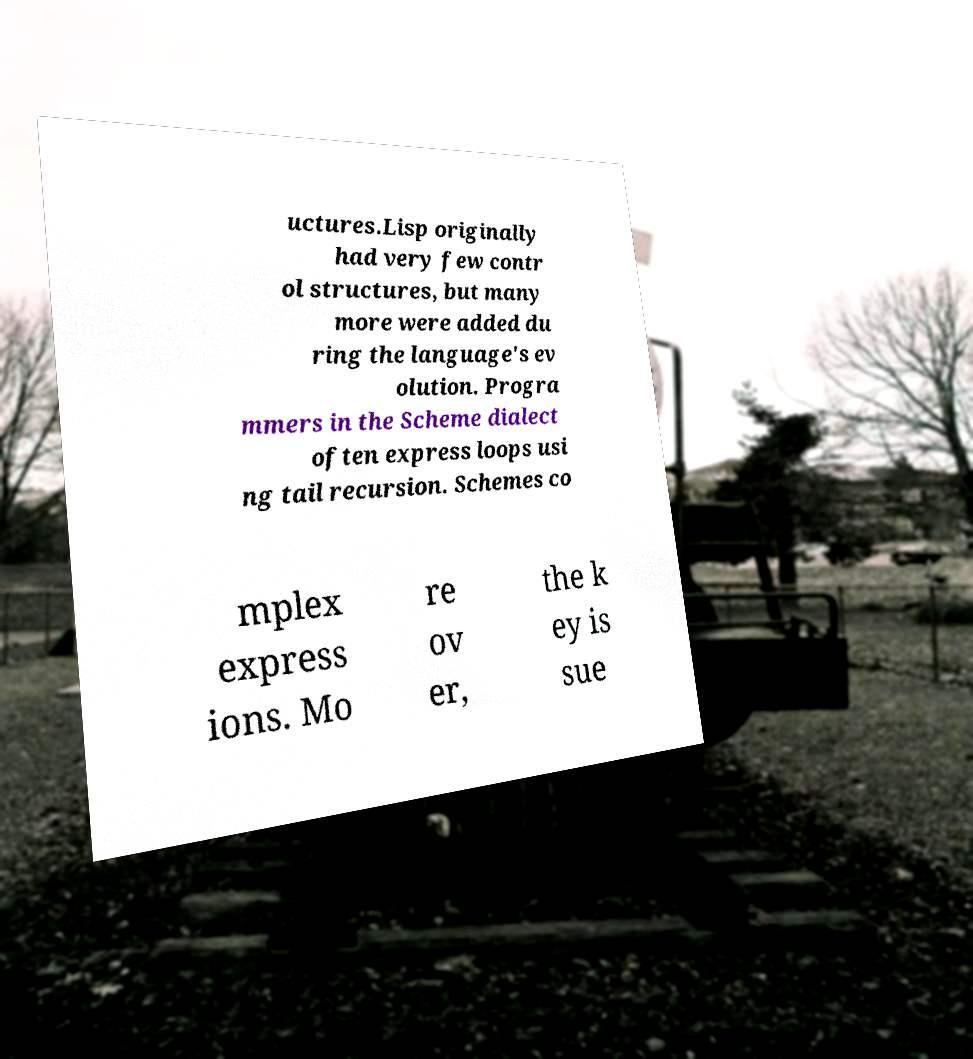Can you accurately transcribe the text from the provided image for me? uctures.Lisp originally had very few contr ol structures, but many more were added du ring the language's ev olution. Progra mmers in the Scheme dialect often express loops usi ng tail recursion. Schemes co mplex express ions. Mo re ov er, the k ey is sue 